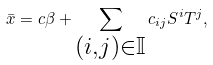Convert formula to latex. <formula><loc_0><loc_0><loc_500><loc_500>\bar { x } = c \beta + \sum _ { \substack { ( i , j ) \in \mathbb { I } } } c _ { i j } S ^ { i } T ^ { j } ,</formula> 